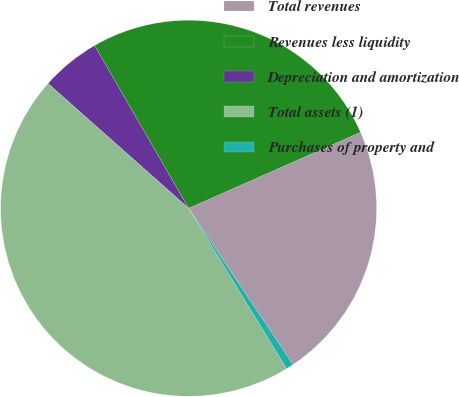Convert chart to OTSL. <chart><loc_0><loc_0><loc_500><loc_500><pie_chart><fcel>Total revenues<fcel>Revenues less liquidity<fcel>Depreciation and amortization<fcel>Total assets (1)<fcel>Purchases of property and<nl><fcel>22.25%<fcel>26.71%<fcel>5.11%<fcel>45.28%<fcel>0.65%<nl></chart> 